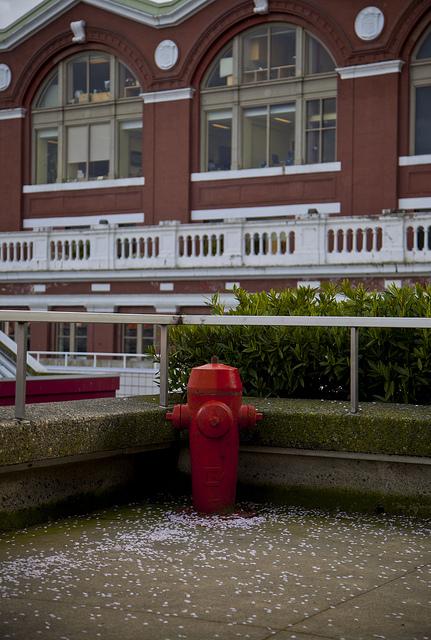What color is the fire hydrant?
Short answer required. Red. What color is the ground under the fire hydrant?
Concise answer only. Brown. Is there a bush in the picture?
Short answer required. Yes. 